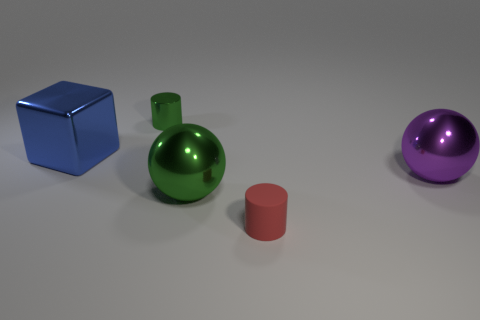Is there anything else that has the same material as the large blue thing?
Your response must be concise. Yes. The object that is left of the cylinder that is behind the tiny rubber object that is on the left side of the big purple metallic thing is made of what material?
Offer a very short reply. Metal. Is the blue thing the same shape as the big green thing?
Make the answer very short. No. There is a big green thing that is the same shape as the large purple thing; what is it made of?
Provide a succinct answer. Metal. What number of small metallic cylinders have the same color as the small metallic thing?
Your response must be concise. 0. There is a purple sphere that is the same material as the big cube; what is its size?
Offer a very short reply. Large. What number of gray objects are either big shiny balls or metallic cylinders?
Your response must be concise. 0. There is a sphere in front of the large purple metal ball; what number of big green objects are on the left side of it?
Give a very brief answer. 0. Is the number of small green cylinders behind the small green metal cylinder greater than the number of tiny red rubber cylinders that are behind the red object?
Offer a very short reply. No. What is the large green sphere made of?
Your answer should be compact. Metal. 